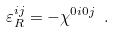Convert formula to latex. <formula><loc_0><loc_0><loc_500><loc_500>\varepsilon _ { R } ^ { i j } = - \chi ^ { 0 i 0 j } \ .</formula> 